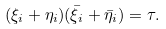<formula> <loc_0><loc_0><loc_500><loc_500>( \xi _ { i } + \eta _ { i } ) ( \bar { \xi } _ { i } + \bar { \eta } _ { i } ) = \tau .</formula> 